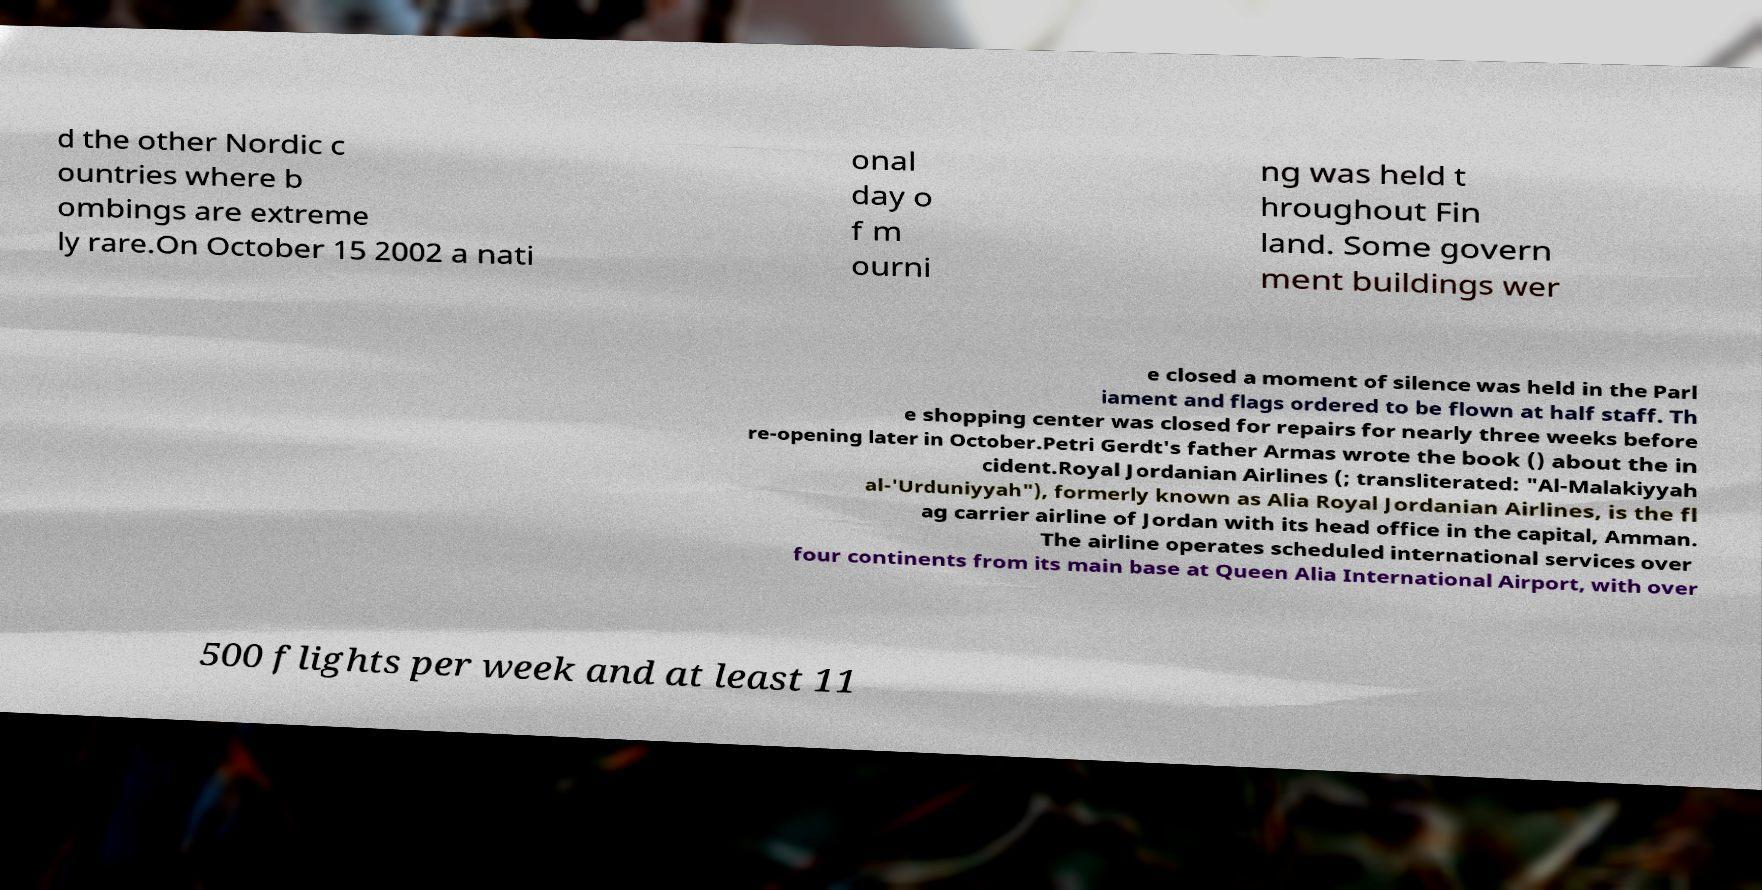Please identify and transcribe the text found in this image. d the other Nordic c ountries where b ombings are extreme ly rare.On October 15 2002 a nati onal day o f m ourni ng was held t hroughout Fin land. Some govern ment buildings wer e closed a moment of silence was held in the Parl iament and flags ordered to be flown at half staff. Th e shopping center was closed for repairs for nearly three weeks before re-opening later in October.Petri Gerdt's father Armas wrote the book () about the in cident.Royal Jordanian Airlines (; transliterated: "Al-Malakiyyah al-'Urduniyyah"), formerly known as Alia Royal Jordanian Airlines, is the fl ag carrier airline of Jordan with its head office in the capital, Amman. The airline operates scheduled international services over four continents from its main base at Queen Alia International Airport, with over 500 flights per week and at least 11 